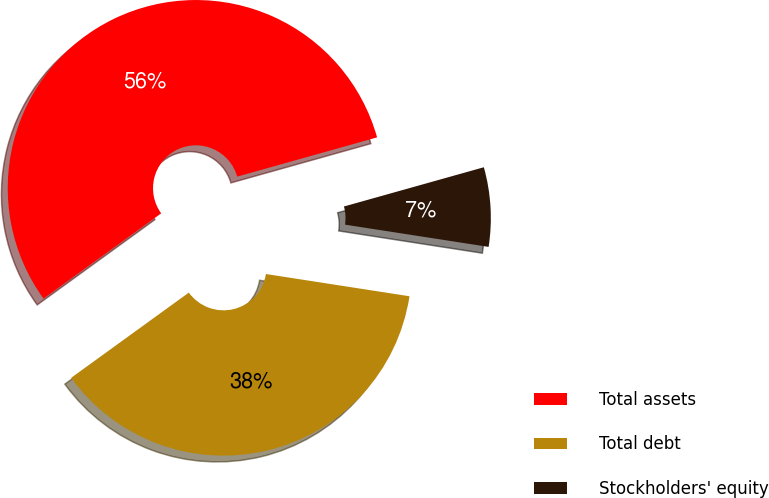<chart> <loc_0><loc_0><loc_500><loc_500><pie_chart><fcel>Total assets<fcel>Total debt<fcel>Stockholders' equity<nl><fcel>55.63%<fcel>37.58%<fcel>6.8%<nl></chart> 